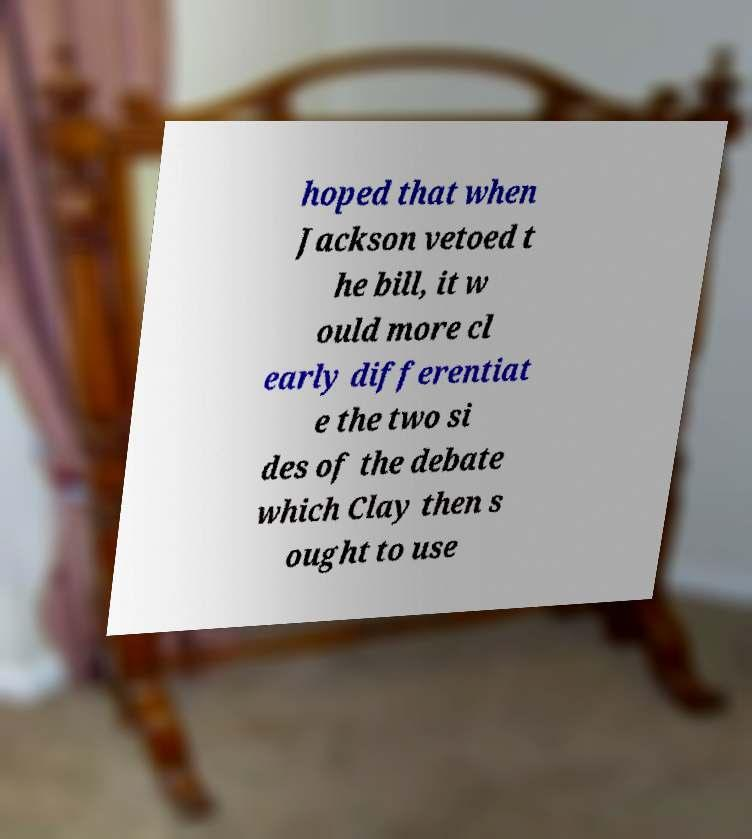I need the written content from this picture converted into text. Can you do that? hoped that when Jackson vetoed t he bill, it w ould more cl early differentiat e the two si des of the debate which Clay then s ought to use 